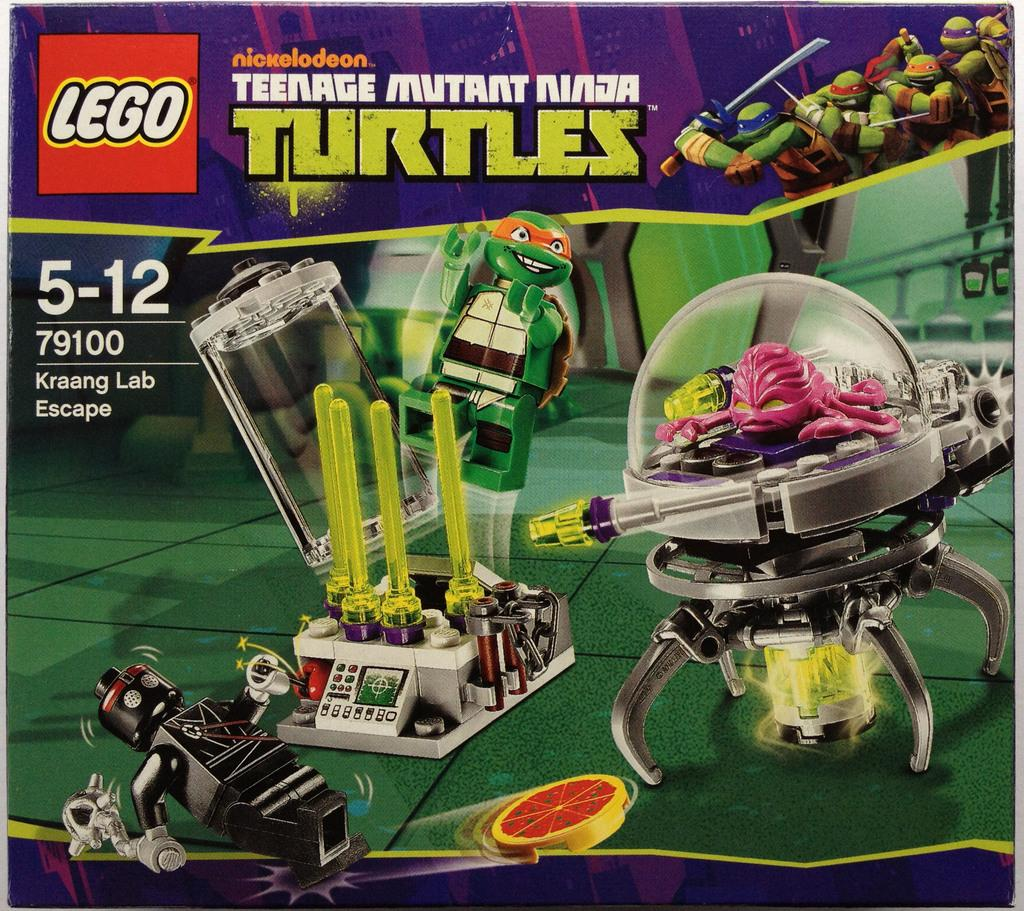<image>
Summarize the visual content of the image. A Teenage Mutant Ninja Turtle Lego toy set. 